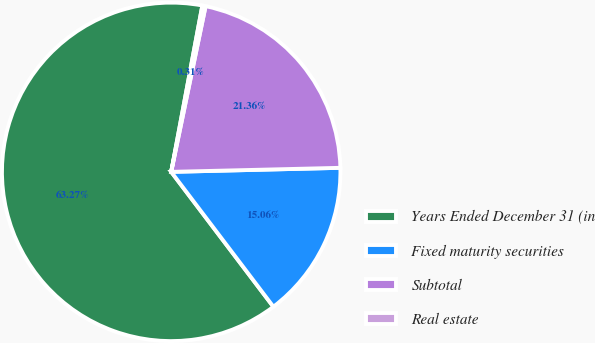Convert chart to OTSL. <chart><loc_0><loc_0><loc_500><loc_500><pie_chart><fcel>Years Ended December 31 (in<fcel>Fixed maturity securities<fcel>Subtotal<fcel>Real estate<nl><fcel>63.26%<fcel>15.06%<fcel>21.36%<fcel>0.31%<nl></chart> 